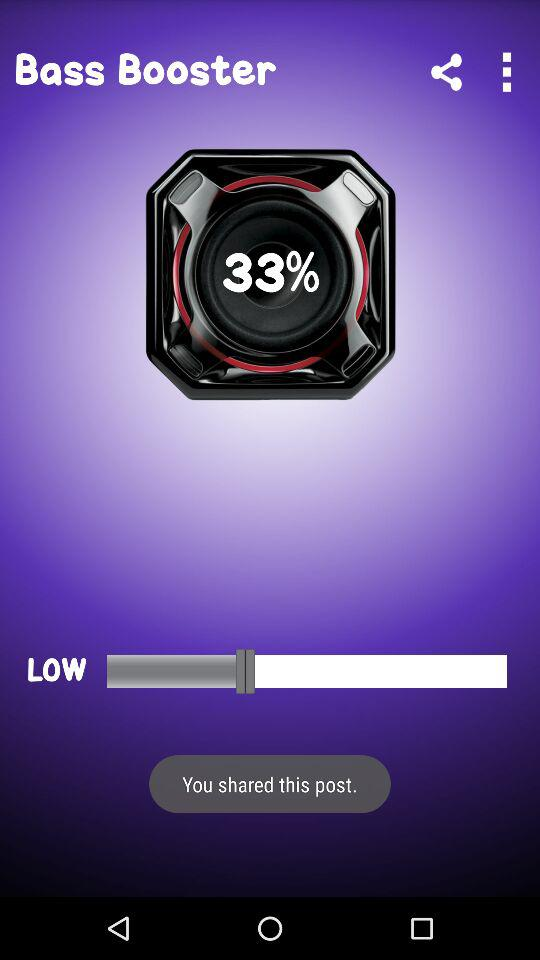What is the name of application? The name of the application is "Bass Booster". 